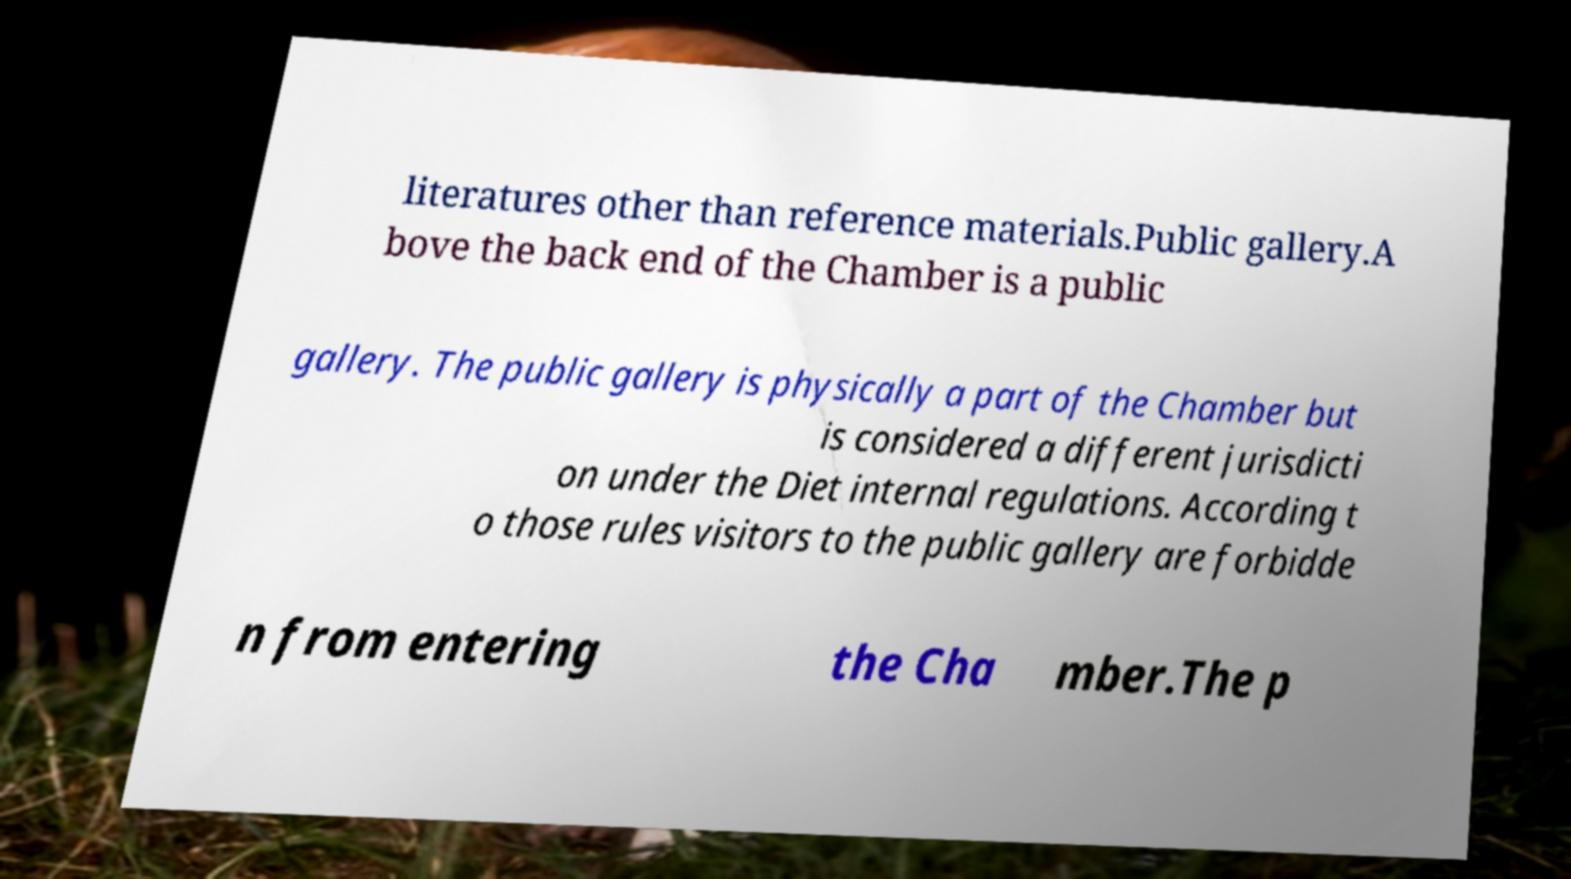Please read and relay the text visible in this image. What does it say? literatures other than reference materials.Public gallery.A bove the back end of the Chamber is a public gallery. The public gallery is physically a part of the Chamber but is considered a different jurisdicti on under the Diet internal regulations. According t o those rules visitors to the public gallery are forbidde n from entering the Cha mber.The p 